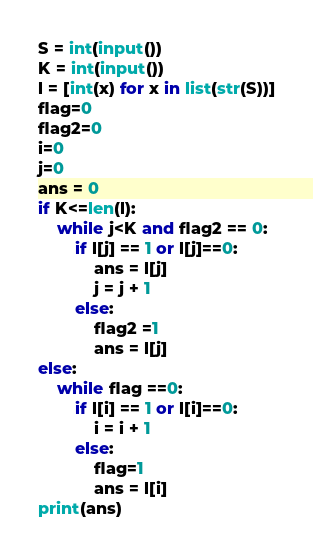Convert code to text. <code><loc_0><loc_0><loc_500><loc_500><_Python_>S = int(input())
K = int(input())
l = [int(x) for x in list(str(S))]
flag=0
flag2=0
i=0
j=0
ans = 0
if K<=len(l):
    while j<K and flag2 == 0:
        if l[j] == 1 or l[j]==0:
            ans = l[j]
            j = j + 1
        else:
            flag2 =1
            ans = l[j]
else:
    while flag ==0:
        if l[i] == 1 or l[i]==0:
            i = i + 1
        else:
            flag=1
            ans = l[i]
print(ans)
</code> 